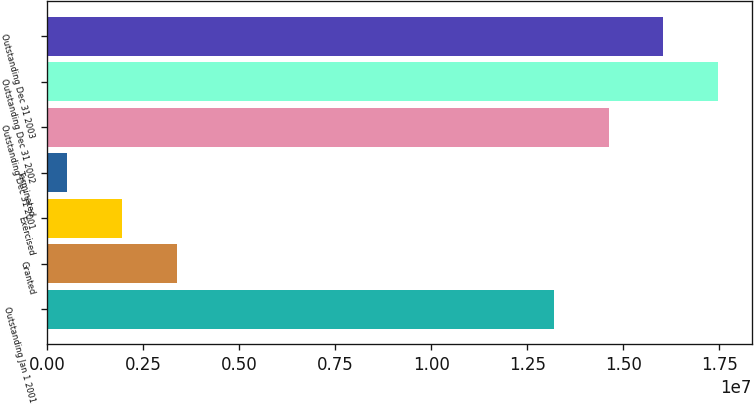Convert chart. <chart><loc_0><loc_0><loc_500><loc_500><bar_chart><fcel>Outstanding Jan 1 2001<fcel>Granted<fcel>Exercised<fcel>Terminated<fcel>Outstanding Dec 31 2001<fcel>Outstanding Dec 31 2002<fcel>Outstanding Dec 31 2003<nl><fcel>1.31867e+07<fcel>3.36322e+06<fcel>1.9329e+06<fcel>502581<fcel>1.4617e+07<fcel>1.74777e+07<fcel>1.60474e+07<nl></chart> 